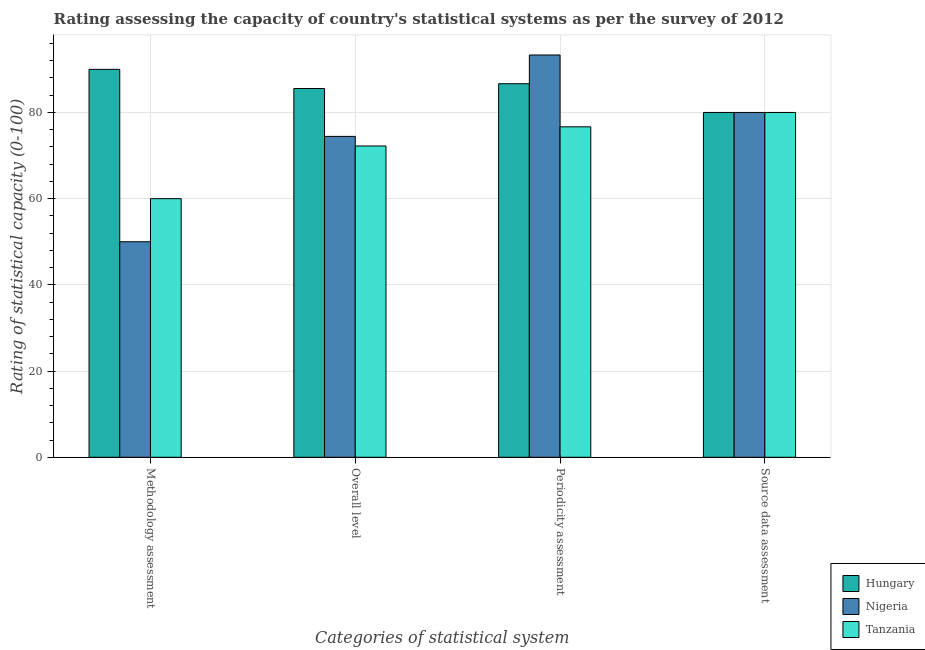Are the number of bars on each tick of the X-axis equal?
Offer a very short reply. Yes. How many bars are there on the 1st tick from the left?
Make the answer very short. 3. What is the label of the 1st group of bars from the left?
Ensure brevity in your answer.  Methodology assessment. Across all countries, what is the maximum source data assessment rating?
Your answer should be compact. 80. Across all countries, what is the minimum periodicity assessment rating?
Offer a terse response. 76.67. In which country was the periodicity assessment rating maximum?
Make the answer very short. Nigeria. In which country was the periodicity assessment rating minimum?
Ensure brevity in your answer.  Tanzania. What is the total periodicity assessment rating in the graph?
Offer a very short reply. 256.67. What is the difference between the periodicity assessment rating in Tanzania and that in Nigeria?
Offer a very short reply. -16.67. What is the difference between the overall level rating in Tanzania and the methodology assessment rating in Hungary?
Keep it short and to the point. -17.78. What is the average periodicity assessment rating per country?
Your answer should be compact. 85.56. What is the difference between the methodology assessment rating and source data assessment rating in Nigeria?
Provide a short and direct response. -30. What is the ratio of the periodicity assessment rating in Nigeria to that in Hungary?
Provide a succinct answer. 1.08. What is the difference between the highest and the second highest periodicity assessment rating?
Keep it short and to the point. 6.67. Is the sum of the source data assessment rating in Tanzania and Hungary greater than the maximum overall level rating across all countries?
Your response must be concise. Yes. Is it the case that in every country, the sum of the methodology assessment rating and source data assessment rating is greater than the sum of periodicity assessment rating and overall level rating?
Make the answer very short. No. What does the 1st bar from the left in Overall level represents?
Your response must be concise. Hungary. What does the 1st bar from the right in Methodology assessment represents?
Your answer should be very brief. Tanzania. How many bars are there?
Offer a very short reply. 12. Are all the bars in the graph horizontal?
Your answer should be compact. No. How many countries are there in the graph?
Ensure brevity in your answer.  3. What is the difference between two consecutive major ticks on the Y-axis?
Make the answer very short. 20. Does the graph contain any zero values?
Provide a succinct answer. No. Does the graph contain grids?
Provide a short and direct response. Yes. Where does the legend appear in the graph?
Provide a short and direct response. Bottom right. How many legend labels are there?
Provide a short and direct response. 3. How are the legend labels stacked?
Give a very brief answer. Vertical. What is the title of the graph?
Offer a terse response. Rating assessing the capacity of country's statistical systems as per the survey of 2012 . Does "China" appear as one of the legend labels in the graph?
Give a very brief answer. No. What is the label or title of the X-axis?
Your response must be concise. Categories of statistical system. What is the label or title of the Y-axis?
Your answer should be very brief. Rating of statistical capacity (0-100). What is the Rating of statistical capacity (0-100) of Hungary in Overall level?
Give a very brief answer. 85.56. What is the Rating of statistical capacity (0-100) of Nigeria in Overall level?
Give a very brief answer. 74.44. What is the Rating of statistical capacity (0-100) in Tanzania in Overall level?
Ensure brevity in your answer.  72.22. What is the Rating of statistical capacity (0-100) of Hungary in Periodicity assessment?
Offer a very short reply. 86.67. What is the Rating of statistical capacity (0-100) in Nigeria in Periodicity assessment?
Keep it short and to the point. 93.33. What is the Rating of statistical capacity (0-100) in Tanzania in Periodicity assessment?
Provide a short and direct response. 76.67. What is the Rating of statistical capacity (0-100) in Hungary in Source data assessment?
Provide a succinct answer. 80. What is the Rating of statistical capacity (0-100) of Nigeria in Source data assessment?
Keep it short and to the point. 80. What is the Rating of statistical capacity (0-100) of Tanzania in Source data assessment?
Provide a succinct answer. 80. Across all Categories of statistical system, what is the maximum Rating of statistical capacity (0-100) in Nigeria?
Offer a very short reply. 93.33. Across all Categories of statistical system, what is the maximum Rating of statistical capacity (0-100) of Tanzania?
Your answer should be very brief. 80. Across all Categories of statistical system, what is the minimum Rating of statistical capacity (0-100) in Hungary?
Your answer should be very brief. 80. Across all Categories of statistical system, what is the minimum Rating of statistical capacity (0-100) in Nigeria?
Offer a very short reply. 50. Across all Categories of statistical system, what is the minimum Rating of statistical capacity (0-100) of Tanzania?
Your answer should be compact. 60. What is the total Rating of statistical capacity (0-100) of Hungary in the graph?
Give a very brief answer. 342.22. What is the total Rating of statistical capacity (0-100) of Nigeria in the graph?
Your answer should be compact. 297.78. What is the total Rating of statistical capacity (0-100) of Tanzania in the graph?
Make the answer very short. 288.89. What is the difference between the Rating of statistical capacity (0-100) in Hungary in Methodology assessment and that in Overall level?
Your response must be concise. 4.44. What is the difference between the Rating of statistical capacity (0-100) of Nigeria in Methodology assessment and that in Overall level?
Your answer should be very brief. -24.44. What is the difference between the Rating of statistical capacity (0-100) of Tanzania in Methodology assessment and that in Overall level?
Provide a succinct answer. -12.22. What is the difference between the Rating of statistical capacity (0-100) in Nigeria in Methodology assessment and that in Periodicity assessment?
Provide a short and direct response. -43.33. What is the difference between the Rating of statistical capacity (0-100) of Tanzania in Methodology assessment and that in Periodicity assessment?
Make the answer very short. -16.67. What is the difference between the Rating of statistical capacity (0-100) in Hungary in Methodology assessment and that in Source data assessment?
Provide a short and direct response. 10. What is the difference between the Rating of statistical capacity (0-100) of Tanzania in Methodology assessment and that in Source data assessment?
Your answer should be compact. -20. What is the difference between the Rating of statistical capacity (0-100) of Hungary in Overall level and that in Periodicity assessment?
Your response must be concise. -1.11. What is the difference between the Rating of statistical capacity (0-100) of Nigeria in Overall level and that in Periodicity assessment?
Keep it short and to the point. -18.89. What is the difference between the Rating of statistical capacity (0-100) of Tanzania in Overall level and that in Periodicity assessment?
Keep it short and to the point. -4.44. What is the difference between the Rating of statistical capacity (0-100) of Hungary in Overall level and that in Source data assessment?
Your answer should be compact. 5.56. What is the difference between the Rating of statistical capacity (0-100) in Nigeria in Overall level and that in Source data assessment?
Offer a terse response. -5.56. What is the difference between the Rating of statistical capacity (0-100) in Tanzania in Overall level and that in Source data assessment?
Offer a very short reply. -7.78. What is the difference between the Rating of statistical capacity (0-100) of Hungary in Periodicity assessment and that in Source data assessment?
Offer a very short reply. 6.67. What is the difference between the Rating of statistical capacity (0-100) of Nigeria in Periodicity assessment and that in Source data assessment?
Provide a succinct answer. 13.33. What is the difference between the Rating of statistical capacity (0-100) of Hungary in Methodology assessment and the Rating of statistical capacity (0-100) of Nigeria in Overall level?
Your response must be concise. 15.56. What is the difference between the Rating of statistical capacity (0-100) of Hungary in Methodology assessment and the Rating of statistical capacity (0-100) of Tanzania in Overall level?
Your answer should be compact. 17.78. What is the difference between the Rating of statistical capacity (0-100) in Nigeria in Methodology assessment and the Rating of statistical capacity (0-100) in Tanzania in Overall level?
Offer a terse response. -22.22. What is the difference between the Rating of statistical capacity (0-100) of Hungary in Methodology assessment and the Rating of statistical capacity (0-100) of Nigeria in Periodicity assessment?
Offer a terse response. -3.33. What is the difference between the Rating of statistical capacity (0-100) of Hungary in Methodology assessment and the Rating of statistical capacity (0-100) of Tanzania in Periodicity assessment?
Ensure brevity in your answer.  13.33. What is the difference between the Rating of statistical capacity (0-100) in Nigeria in Methodology assessment and the Rating of statistical capacity (0-100) in Tanzania in Periodicity assessment?
Give a very brief answer. -26.67. What is the difference between the Rating of statistical capacity (0-100) of Hungary in Methodology assessment and the Rating of statistical capacity (0-100) of Nigeria in Source data assessment?
Provide a short and direct response. 10. What is the difference between the Rating of statistical capacity (0-100) of Hungary in Methodology assessment and the Rating of statistical capacity (0-100) of Tanzania in Source data assessment?
Offer a very short reply. 10. What is the difference between the Rating of statistical capacity (0-100) of Nigeria in Methodology assessment and the Rating of statistical capacity (0-100) of Tanzania in Source data assessment?
Provide a succinct answer. -30. What is the difference between the Rating of statistical capacity (0-100) in Hungary in Overall level and the Rating of statistical capacity (0-100) in Nigeria in Periodicity assessment?
Your answer should be compact. -7.78. What is the difference between the Rating of statistical capacity (0-100) in Hungary in Overall level and the Rating of statistical capacity (0-100) in Tanzania in Periodicity assessment?
Your answer should be very brief. 8.89. What is the difference between the Rating of statistical capacity (0-100) of Nigeria in Overall level and the Rating of statistical capacity (0-100) of Tanzania in Periodicity assessment?
Make the answer very short. -2.22. What is the difference between the Rating of statistical capacity (0-100) of Hungary in Overall level and the Rating of statistical capacity (0-100) of Nigeria in Source data assessment?
Your answer should be compact. 5.56. What is the difference between the Rating of statistical capacity (0-100) in Hungary in Overall level and the Rating of statistical capacity (0-100) in Tanzania in Source data assessment?
Provide a succinct answer. 5.56. What is the difference between the Rating of statistical capacity (0-100) of Nigeria in Overall level and the Rating of statistical capacity (0-100) of Tanzania in Source data assessment?
Offer a terse response. -5.56. What is the difference between the Rating of statistical capacity (0-100) of Nigeria in Periodicity assessment and the Rating of statistical capacity (0-100) of Tanzania in Source data assessment?
Offer a terse response. 13.33. What is the average Rating of statistical capacity (0-100) in Hungary per Categories of statistical system?
Offer a terse response. 85.56. What is the average Rating of statistical capacity (0-100) of Nigeria per Categories of statistical system?
Your answer should be very brief. 74.44. What is the average Rating of statistical capacity (0-100) of Tanzania per Categories of statistical system?
Offer a very short reply. 72.22. What is the difference between the Rating of statistical capacity (0-100) of Nigeria and Rating of statistical capacity (0-100) of Tanzania in Methodology assessment?
Keep it short and to the point. -10. What is the difference between the Rating of statistical capacity (0-100) in Hungary and Rating of statistical capacity (0-100) in Nigeria in Overall level?
Provide a short and direct response. 11.11. What is the difference between the Rating of statistical capacity (0-100) in Hungary and Rating of statistical capacity (0-100) in Tanzania in Overall level?
Offer a terse response. 13.33. What is the difference between the Rating of statistical capacity (0-100) of Nigeria and Rating of statistical capacity (0-100) of Tanzania in Overall level?
Keep it short and to the point. 2.22. What is the difference between the Rating of statistical capacity (0-100) in Hungary and Rating of statistical capacity (0-100) in Nigeria in Periodicity assessment?
Your answer should be very brief. -6.67. What is the difference between the Rating of statistical capacity (0-100) of Hungary and Rating of statistical capacity (0-100) of Tanzania in Periodicity assessment?
Keep it short and to the point. 10. What is the difference between the Rating of statistical capacity (0-100) in Nigeria and Rating of statistical capacity (0-100) in Tanzania in Periodicity assessment?
Make the answer very short. 16.67. What is the difference between the Rating of statistical capacity (0-100) of Nigeria and Rating of statistical capacity (0-100) of Tanzania in Source data assessment?
Provide a short and direct response. 0. What is the ratio of the Rating of statistical capacity (0-100) of Hungary in Methodology assessment to that in Overall level?
Offer a very short reply. 1.05. What is the ratio of the Rating of statistical capacity (0-100) of Nigeria in Methodology assessment to that in Overall level?
Your answer should be very brief. 0.67. What is the ratio of the Rating of statistical capacity (0-100) of Tanzania in Methodology assessment to that in Overall level?
Keep it short and to the point. 0.83. What is the ratio of the Rating of statistical capacity (0-100) in Hungary in Methodology assessment to that in Periodicity assessment?
Your answer should be compact. 1.04. What is the ratio of the Rating of statistical capacity (0-100) in Nigeria in Methodology assessment to that in Periodicity assessment?
Offer a terse response. 0.54. What is the ratio of the Rating of statistical capacity (0-100) in Tanzania in Methodology assessment to that in Periodicity assessment?
Keep it short and to the point. 0.78. What is the ratio of the Rating of statistical capacity (0-100) of Hungary in Overall level to that in Periodicity assessment?
Your response must be concise. 0.99. What is the ratio of the Rating of statistical capacity (0-100) in Nigeria in Overall level to that in Periodicity assessment?
Keep it short and to the point. 0.8. What is the ratio of the Rating of statistical capacity (0-100) of Tanzania in Overall level to that in Periodicity assessment?
Keep it short and to the point. 0.94. What is the ratio of the Rating of statistical capacity (0-100) of Hungary in Overall level to that in Source data assessment?
Your answer should be very brief. 1.07. What is the ratio of the Rating of statistical capacity (0-100) of Nigeria in Overall level to that in Source data assessment?
Your answer should be very brief. 0.93. What is the ratio of the Rating of statistical capacity (0-100) in Tanzania in Overall level to that in Source data assessment?
Provide a succinct answer. 0.9. What is the ratio of the Rating of statistical capacity (0-100) in Tanzania in Periodicity assessment to that in Source data assessment?
Provide a succinct answer. 0.96. What is the difference between the highest and the second highest Rating of statistical capacity (0-100) of Hungary?
Your response must be concise. 3.33. What is the difference between the highest and the second highest Rating of statistical capacity (0-100) in Nigeria?
Your response must be concise. 13.33. What is the difference between the highest and the lowest Rating of statistical capacity (0-100) of Nigeria?
Make the answer very short. 43.33. 